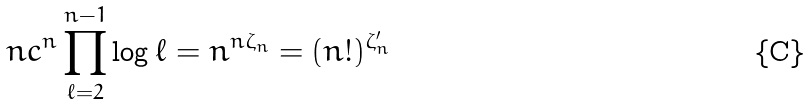Convert formula to latex. <formula><loc_0><loc_0><loc_500><loc_500>n c ^ { n } \prod _ { \ell = 2 } ^ { n - 1 } \log \ell = n ^ { n \zeta _ { n } } = ( n ! ) ^ { \zeta ^ { \prime } _ { n } }</formula> 